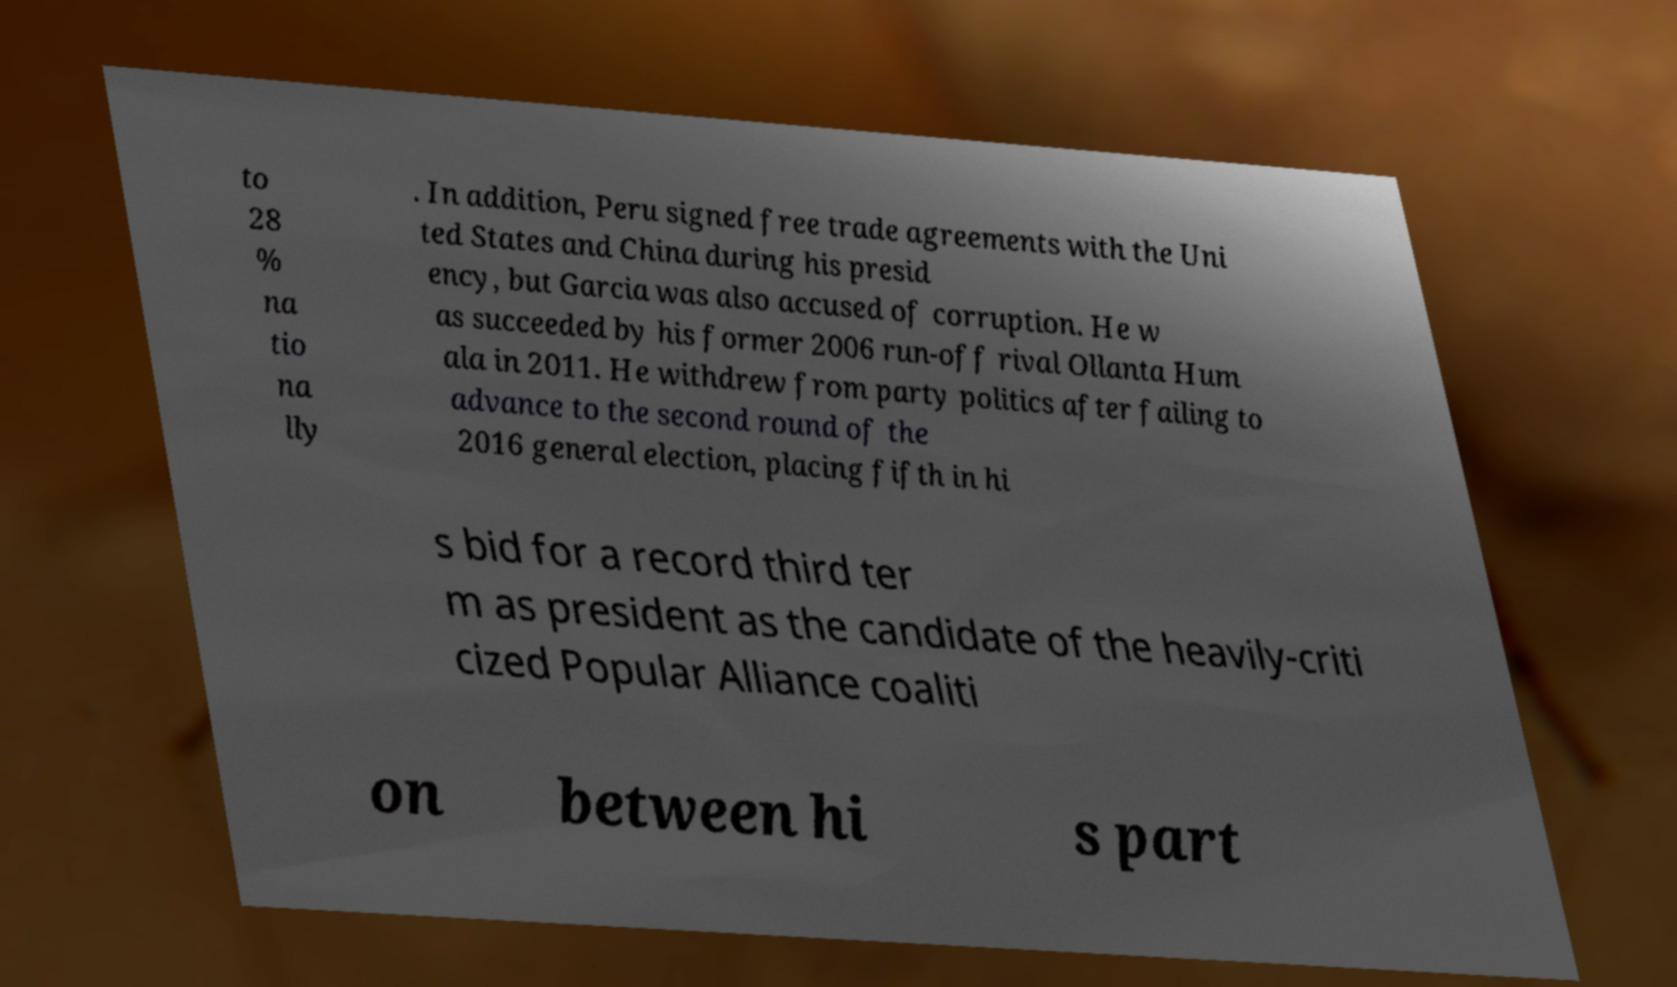Please identify and transcribe the text found in this image. to 28 % na tio na lly . In addition, Peru signed free trade agreements with the Uni ted States and China during his presid ency, but Garcia was also accused of corruption. He w as succeeded by his former 2006 run-off rival Ollanta Hum ala in 2011. He withdrew from party politics after failing to advance to the second round of the 2016 general election, placing fifth in hi s bid for a record third ter m as president as the candidate of the heavily-criti cized Popular Alliance coaliti on between hi s part 